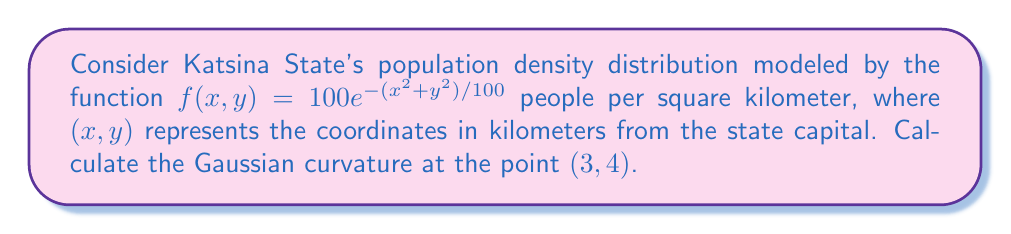What is the answer to this math problem? To compute the Gaussian curvature, we need to follow these steps:

1) The Gaussian curvature K is given by:
   $$K = \frac{f_{xx}f_{yy} - f_{xy}^2}{(1 + f_x^2 + f_y^2)^2}$$
   where subscripts denote partial derivatives.

2) Let's calculate the required partial derivatives:

   $f_x = -\frac{2x}{100} \cdot 100e^{-(x^2+y^2)/100} = -2xe^{-(x^2+y^2)/100}$
   
   $f_y = -\frac{2y}{100} \cdot 100e^{-(x^2+y^2)/100} = -2ye^{-(x^2+y^2)/100}$
   
   $f_{xx} = (-2 + \frac{4x^2}{100})e^{-(x^2+y^2)/100}$
   
   $f_{yy} = (-2 + \frac{4y^2}{100})e^{-(x^2+y^2)/100}$
   
   $f_{xy} = f_{yx} = \frac{4xy}{100}e^{-(x^2+y^2)/100}$

3) Now, let's evaluate these at the point (3,4):

   $f_x(3,4) = -6e^{-25/100}$
   
   $f_y(3,4) = -8e^{-25/100}$
   
   $f_{xx}(3,4) = (-2 + \frac{36}{100})e^{-25/100} = -1.64e^{-25/100}$
   
   $f_{yy}(3,4) = (-2 + \frac{64}{100})e^{-25/100} = -1.36e^{-25/100}$
   
   $f_{xy}(3,4) = \frac{48}{100}e^{-25/100} = 0.48e^{-25/100}$

4) Substituting these values into the Gaussian curvature formula:

   $$K = \frac{(-1.64e^{-25/100})(-1.36e^{-25/100}) - (0.48e^{-25/100})^2}{(1 + (-6e^{-25/100})^2 + (-8e^{-25/100})^2)^2}$$

5) Simplifying:

   $$K = \frac{2.23e^{-0.5} - 0.23e^{-0.5}}{(1 + 36e^{-0.5} + 64e^{-0.5})^2} = \frac{2e^{-0.5}}{(1 + 100e^{-0.5})^2}$$

6) Evaluating this expression numerically:

   $$K \approx 0.00219 \text{ km}^{-2}$$
Answer: $0.00219 \text{ km}^{-2}$ 